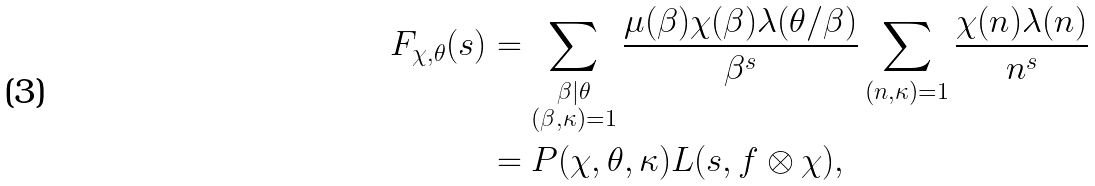<formula> <loc_0><loc_0><loc_500><loc_500>F _ { \chi , \theta } ( s ) & = \sum _ { \substack { \beta | \theta \\ ( \beta , \kappa ) = 1 } } \frac { \mu ( \beta ) \chi ( \beta ) \lambda ( \theta / \beta ) } { \beta ^ { s } } \sum _ { ( n , \kappa ) = 1 } \frac { \chi ( n ) \lambda ( n ) } { n ^ { s } } \\ & = P ( \chi , \theta , \kappa ) L ( s , f \otimes \chi ) ,</formula> 